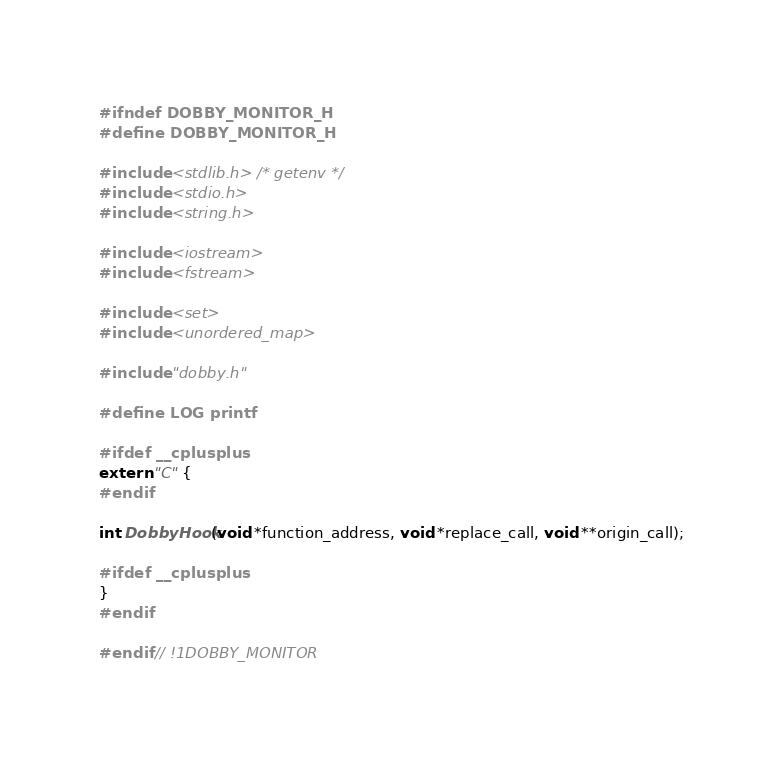Convert code to text. <code><loc_0><loc_0><loc_500><loc_500><_C_>#ifndef DOBBY_MONITOR_H
#define DOBBY_MONITOR_H

#include <stdlib.h> /* getenv */
#include <stdio.h>
#include <string.h>

#include <iostream>
#include <fstream>

#include <set>
#include <unordered_map>

#include "dobby.h"

#define LOG printf

#ifdef __cplusplus
extern "C" {
#endif

int DobbyHook(void *function_address, void *replace_call, void **origin_call);

#ifdef __cplusplus
}
#endif

#endif // !1DOBBY_MONITOR
</code> 